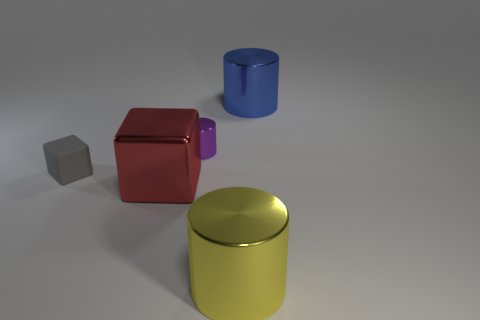Add 3 small cylinders. How many objects exist? 8 Subtract all cylinders. How many objects are left? 2 Add 5 large purple cubes. How many large purple cubes exist? 5 Subtract 0 cyan cubes. How many objects are left? 5 Subtract all big yellow metallic cubes. Subtract all metallic cubes. How many objects are left? 4 Add 5 red metallic objects. How many red metallic objects are left? 6 